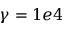Convert formula to latex. <formula><loc_0><loc_0><loc_500><loc_500>\gamma = 1 e 4</formula> 